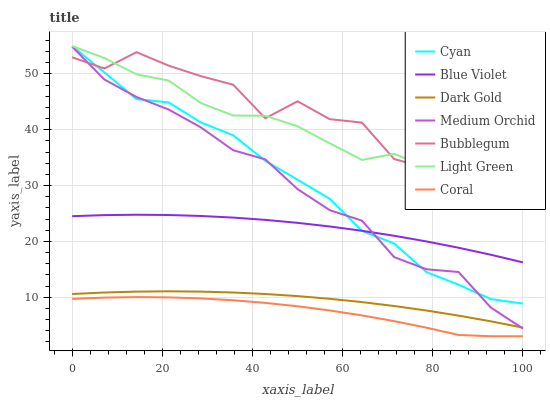Does Coral have the minimum area under the curve?
Answer yes or no. Yes. Does Bubblegum have the maximum area under the curve?
Answer yes or no. Yes. Does Medium Orchid have the minimum area under the curve?
Answer yes or no. No. Does Medium Orchid have the maximum area under the curve?
Answer yes or no. No. Is Dark Gold the smoothest?
Answer yes or no. Yes. Is Bubblegum the roughest?
Answer yes or no. Yes. Is Coral the smoothest?
Answer yes or no. No. Is Coral the roughest?
Answer yes or no. No. Does Coral have the lowest value?
Answer yes or no. Yes. Does Medium Orchid have the lowest value?
Answer yes or no. No. Does Cyan have the highest value?
Answer yes or no. Yes. Does Medium Orchid have the highest value?
Answer yes or no. No. Is Coral less than Light Green?
Answer yes or no. Yes. Is Bubblegum greater than Blue Violet?
Answer yes or no. Yes. Does Light Green intersect Cyan?
Answer yes or no. Yes. Is Light Green less than Cyan?
Answer yes or no. No. Is Light Green greater than Cyan?
Answer yes or no. No. Does Coral intersect Light Green?
Answer yes or no. No. 